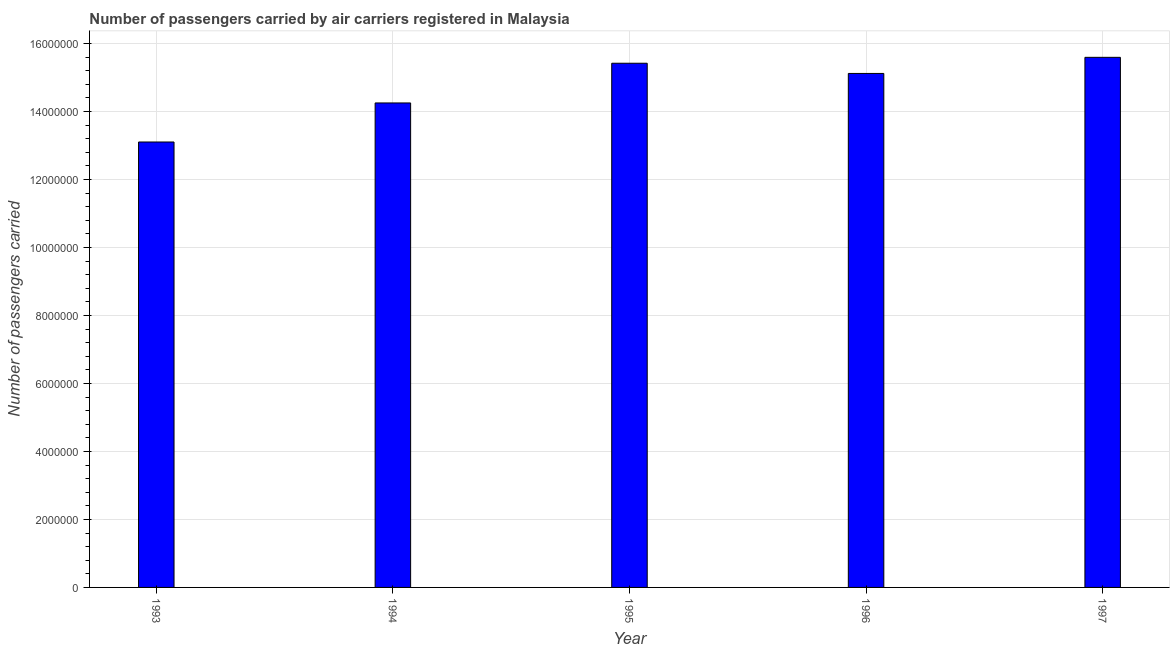What is the title of the graph?
Your response must be concise. Number of passengers carried by air carriers registered in Malaysia. What is the label or title of the X-axis?
Offer a very short reply. Year. What is the label or title of the Y-axis?
Provide a succinct answer. Number of passengers carried. What is the number of passengers carried in 1993?
Ensure brevity in your answer.  1.31e+07. Across all years, what is the maximum number of passengers carried?
Your answer should be compact. 1.56e+07. Across all years, what is the minimum number of passengers carried?
Provide a succinct answer. 1.31e+07. In which year was the number of passengers carried minimum?
Keep it short and to the point. 1993. What is the sum of the number of passengers carried?
Your answer should be very brief. 7.35e+07. What is the difference between the number of passengers carried in 1993 and 1996?
Keep it short and to the point. -2.02e+06. What is the average number of passengers carried per year?
Keep it short and to the point. 1.47e+07. What is the median number of passengers carried?
Your response must be concise. 1.51e+07. Do a majority of the years between 1994 and 1996 (inclusive) have number of passengers carried greater than 13600000 ?
Your answer should be very brief. Yes. What is the ratio of the number of passengers carried in 1996 to that in 1997?
Offer a terse response. 0.97. Is the difference between the number of passengers carried in 1994 and 1996 greater than the difference between any two years?
Give a very brief answer. No. What is the difference between the highest and the second highest number of passengers carried?
Offer a terse response. 1.74e+05. Is the sum of the number of passengers carried in 1993 and 1994 greater than the maximum number of passengers carried across all years?
Your answer should be very brief. Yes. What is the difference between the highest and the lowest number of passengers carried?
Your answer should be compact. 2.49e+06. In how many years, is the number of passengers carried greater than the average number of passengers carried taken over all years?
Your response must be concise. 3. Are all the bars in the graph horizontal?
Provide a succinct answer. No. How many years are there in the graph?
Make the answer very short. 5. Are the values on the major ticks of Y-axis written in scientific E-notation?
Provide a succinct answer. No. What is the Number of passengers carried in 1993?
Offer a terse response. 1.31e+07. What is the Number of passengers carried in 1994?
Make the answer very short. 1.42e+07. What is the Number of passengers carried in 1995?
Give a very brief answer. 1.54e+07. What is the Number of passengers carried of 1996?
Offer a very short reply. 1.51e+07. What is the Number of passengers carried in 1997?
Ensure brevity in your answer.  1.56e+07. What is the difference between the Number of passengers carried in 1993 and 1994?
Your answer should be very brief. -1.15e+06. What is the difference between the Number of passengers carried in 1993 and 1995?
Ensure brevity in your answer.  -2.32e+06. What is the difference between the Number of passengers carried in 1993 and 1996?
Your answer should be compact. -2.02e+06. What is the difference between the Number of passengers carried in 1993 and 1997?
Offer a very short reply. -2.49e+06. What is the difference between the Number of passengers carried in 1994 and 1995?
Provide a succinct answer. -1.17e+06. What is the difference between the Number of passengers carried in 1994 and 1996?
Ensure brevity in your answer.  -8.68e+05. What is the difference between the Number of passengers carried in 1994 and 1997?
Offer a very short reply. -1.34e+06. What is the difference between the Number of passengers carried in 1995 and 1996?
Keep it short and to the point. 3.00e+05. What is the difference between the Number of passengers carried in 1995 and 1997?
Your response must be concise. -1.74e+05. What is the difference between the Number of passengers carried in 1996 and 1997?
Offer a terse response. -4.74e+05. What is the ratio of the Number of passengers carried in 1993 to that in 1994?
Keep it short and to the point. 0.92. What is the ratio of the Number of passengers carried in 1993 to that in 1995?
Ensure brevity in your answer.  0.85. What is the ratio of the Number of passengers carried in 1993 to that in 1996?
Keep it short and to the point. 0.87. What is the ratio of the Number of passengers carried in 1993 to that in 1997?
Ensure brevity in your answer.  0.84. What is the ratio of the Number of passengers carried in 1994 to that in 1995?
Provide a succinct answer. 0.92. What is the ratio of the Number of passengers carried in 1994 to that in 1996?
Provide a short and direct response. 0.94. What is the ratio of the Number of passengers carried in 1994 to that in 1997?
Give a very brief answer. 0.91. What is the ratio of the Number of passengers carried in 1996 to that in 1997?
Ensure brevity in your answer.  0.97. 